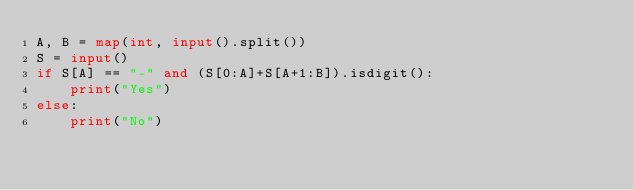<code> <loc_0><loc_0><loc_500><loc_500><_Python_>A, B = map(int, input().split())
S = input() 
if S[A] == "-" and (S[0:A]+S[A+1:B]).isdigit():
    print("Yes")
else:
    print("No")</code> 